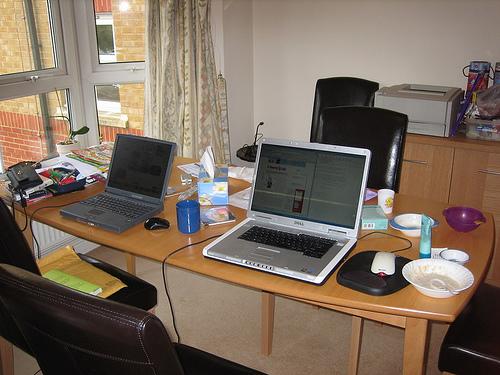How many chairs are in the picture?
Keep it brief. 4. How many cups are on the desk?
Concise answer only. 2. How many comps are on the desk?
Answer briefly. 2. Has someone been eating here recently?
Write a very short answer. Yes. How many laptops are there?
Be succinct. 2. Are there tissues on this desk?
Keep it brief. Yes. 